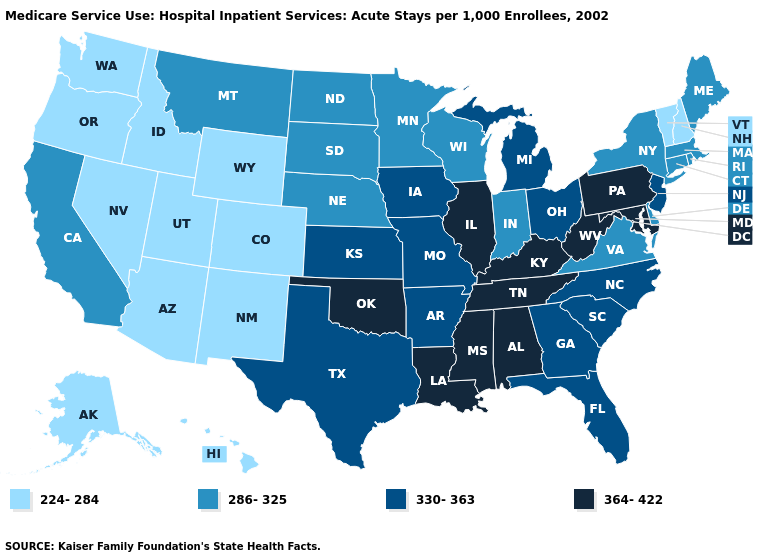What is the lowest value in states that border New Hampshire?
Be succinct. 224-284. Name the states that have a value in the range 364-422?
Be succinct. Alabama, Illinois, Kentucky, Louisiana, Maryland, Mississippi, Oklahoma, Pennsylvania, Tennessee, West Virginia. What is the value of Louisiana?
Be succinct. 364-422. What is the value of South Carolina?
Short answer required. 330-363. Name the states that have a value in the range 330-363?
Write a very short answer. Arkansas, Florida, Georgia, Iowa, Kansas, Michigan, Missouri, New Jersey, North Carolina, Ohio, South Carolina, Texas. What is the value of Oklahoma?
Concise answer only. 364-422. What is the highest value in the USA?
Short answer required. 364-422. Does South Dakota have the same value as Illinois?
Give a very brief answer. No. Name the states that have a value in the range 364-422?
Quick response, please. Alabama, Illinois, Kentucky, Louisiana, Maryland, Mississippi, Oklahoma, Pennsylvania, Tennessee, West Virginia. What is the value of Colorado?
Keep it brief. 224-284. Does Kentucky have a lower value than Connecticut?
Quick response, please. No. Does Oklahoma have the highest value in the USA?
Short answer required. Yes. Name the states that have a value in the range 330-363?
Short answer required. Arkansas, Florida, Georgia, Iowa, Kansas, Michigan, Missouri, New Jersey, North Carolina, Ohio, South Carolina, Texas. Is the legend a continuous bar?
Be succinct. No. Does the map have missing data?
Give a very brief answer. No. 